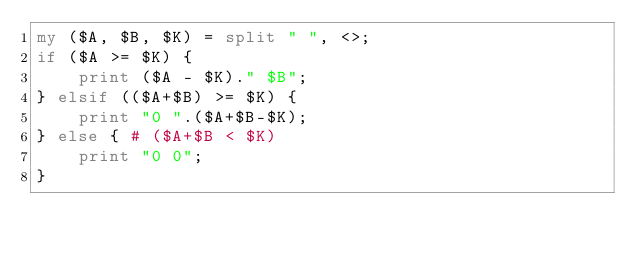<code> <loc_0><loc_0><loc_500><loc_500><_Perl_>my ($A, $B, $K) = split " ", <>;
if ($A >= $K) {
    print ($A - $K)." $B";
} elsif (($A+$B) >= $K) {
    print "0 ".($A+$B-$K);
} else { # ($A+$B < $K)
    print "0 0";
}
</code> 